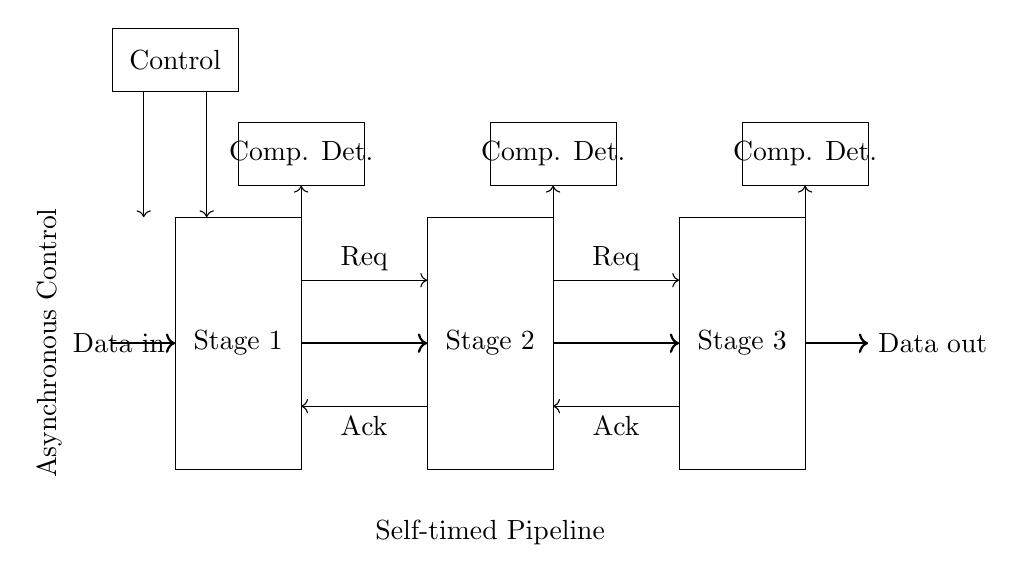What are the stages present in the circuit? The stages in the circuit are Stage 1, Stage 2, and Stage 3, each shown as rectangles in the diagram.
Answer: Stage 1, Stage 2, Stage 3 What is the primary function of the 'Control' component? The 'Control' component manages the operation of the self-timed pipeline by coordinating the requests and acknowledgments between stages.
Answer: Coordination How many handshake signals are there? There are four handshake signals: two request signals and two acknowledgment signals, represented by arrows between stages.
Answer: Four What type of pipeline is represented in this circuit? The circuit represents a self-timed pipeline, which allows for asynchronous data processing without global clock signals.
Answer: Self-timed pipeline What is the purpose of the 'Completion Detection' boxes? The 'Completion Detection' boxes signal when a stage has finished processing its data, allowing the next stage to begin its operation.
Answer: Signal finished processing How does the asynchronous control affect data processing efficiency? The asynchronous control allows independent operation of the stages, reducing idle time and improving overall data throughput in high-performance computing.
Answer: Reduces idle time What is the direction of data flow in this circuit? The data flows from left to right, entering at 'Data in' and exiting at 'Data out' after passing through each stage.
Answer: Left to right 